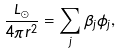Convert formula to latex. <formula><loc_0><loc_0><loc_500><loc_500>\frac { L _ { \odot } } { 4 \pi r ^ { 2 } } = \sum _ { j } \beta _ { j } \phi _ { j } ,</formula> 